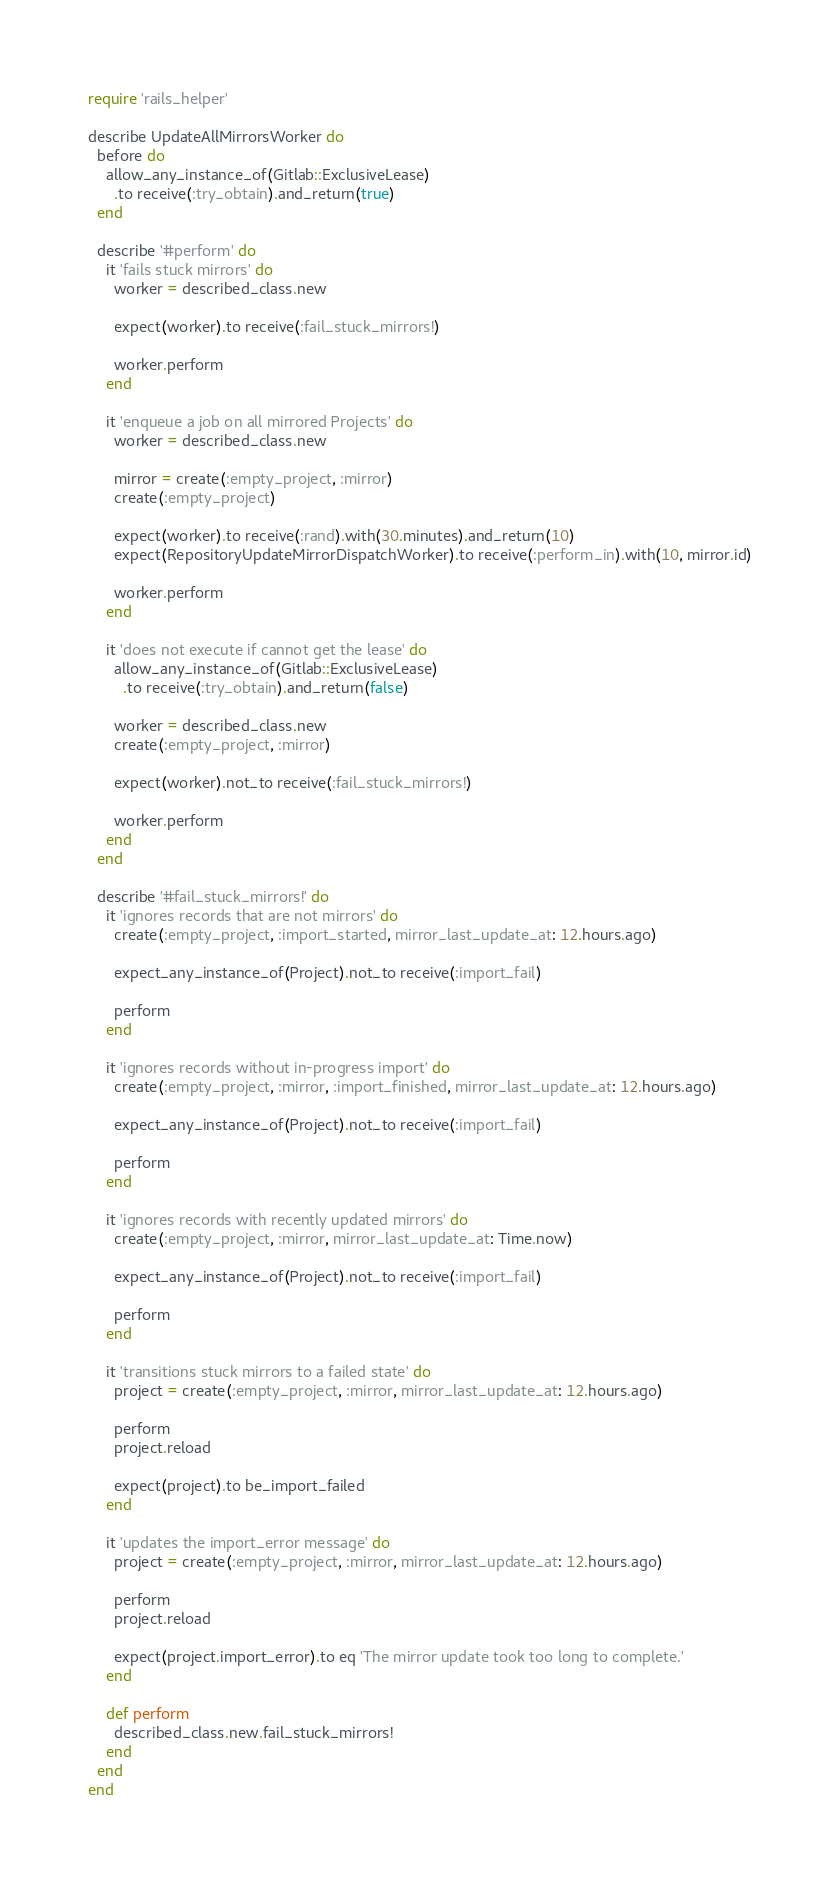<code> <loc_0><loc_0><loc_500><loc_500><_Ruby_>require 'rails_helper'

describe UpdateAllMirrorsWorker do
  before do
    allow_any_instance_of(Gitlab::ExclusiveLease)
      .to receive(:try_obtain).and_return(true)
  end

  describe '#perform' do
    it 'fails stuck mirrors' do
      worker = described_class.new

      expect(worker).to receive(:fail_stuck_mirrors!)

      worker.perform
    end

    it 'enqueue a job on all mirrored Projects' do
      worker = described_class.new

      mirror = create(:empty_project, :mirror)
      create(:empty_project)

      expect(worker).to receive(:rand).with(30.minutes).and_return(10)
      expect(RepositoryUpdateMirrorDispatchWorker).to receive(:perform_in).with(10, mirror.id)

      worker.perform
    end

    it 'does not execute if cannot get the lease' do
      allow_any_instance_of(Gitlab::ExclusiveLease)
        .to receive(:try_obtain).and_return(false)

      worker = described_class.new
      create(:empty_project, :mirror)

      expect(worker).not_to receive(:fail_stuck_mirrors!)

      worker.perform
    end
  end

  describe '#fail_stuck_mirrors!' do
    it 'ignores records that are not mirrors' do
      create(:empty_project, :import_started, mirror_last_update_at: 12.hours.ago)

      expect_any_instance_of(Project).not_to receive(:import_fail)

      perform
    end

    it 'ignores records without in-progress import' do
      create(:empty_project, :mirror, :import_finished, mirror_last_update_at: 12.hours.ago)

      expect_any_instance_of(Project).not_to receive(:import_fail)

      perform
    end

    it 'ignores records with recently updated mirrors' do
      create(:empty_project, :mirror, mirror_last_update_at: Time.now)

      expect_any_instance_of(Project).not_to receive(:import_fail)

      perform
    end

    it 'transitions stuck mirrors to a failed state' do
      project = create(:empty_project, :mirror, mirror_last_update_at: 12.hours.ago)

      perform
      project.reload

      expect(project).to be_import_failed
    end

    it 'updates the import_error message' do
      project = create(:empty_project, :mirror, mirror_last_update_at: 12.hours.ago)

      perform
      project.reload

      expect(project.import_error).to eq 'The mirror update took too long to complete.'
    end

    def perform
      described_class.new.fail_stuck_mirrors!
    end
  end
end
</code> 